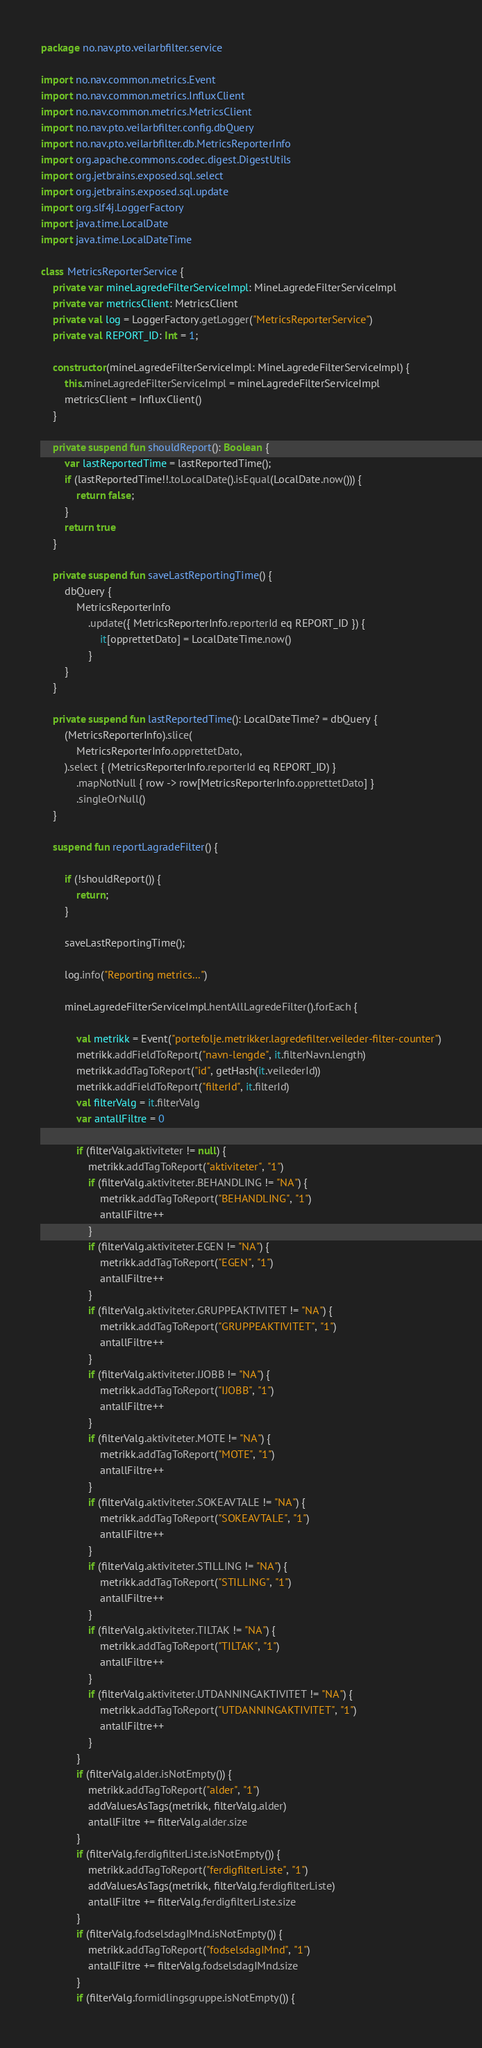Convert code to text. <code><loc_0><loc_0><loc_500><loc_500><_Kotlin_>package no.nav.pto.veilarbfilter.service

import no.nav.common.metrics.Event
import no.nav.common.metrics.InfluxClient
import no.nav.common.metrics.MetricsClient
import no.nav.pto.veilarbfilter.config.dbQuery
import no.nav.pto.veilarbfilter.db.MetricsReporterInfo
import org.apache.commons.codec.digest.DigestUtils
import org.jetbrains.exposed.sql.select
import org.jetbrains.exposed.sql.update
import org.slf4j.LoggerFactory
import java.time.LocalDate
import java.time.LocalDateTime

class MetricsReporterService {
    private var mineLagredeFilterServiceImpl: MineLagredeFilterServiceImpl
    private var metricsClient: MetricsClient
    private val log = LoggerFactory.getLogger("MetricsReporterService")
    private val REPORT_ID: Int = 1;

    constructor(mineLagredeFilterServiceImpl: MineLagredeFilterServiceImpl) {
        this.mineLagredeFilterServiceImpl = mineLagredeFilterServiceImpl
        metricsClient = InfluxClient()
    }

    private suspend fun shouldReport(): Boolean {
        var lastReportedTime = lastReportedTime();
        if (lastReportedTime!!.toLocalDate().isEqual(LocalDate.now())) {
            return false;
        }
        return true
    }

    private suspend fun saveLastReportingTime() {
        dbQuery {
            MetricsReporterInfo
                .update({ MetricsReporterInfo.reporterId eq REPORT_ID }) {
                    it[opprettetDato] = LocalDateTime.now()
                }
        }
    }

    private suspend fun lastReportedTime(): LocalDateTime? = dbQuery {
        (MetricsReporterInfo).slice(
            MetricsReporterInfo.opprettetDato,
        ).select { (MetricsReporterInfo.reporterId eq REPORT_ID) }
            .mapNotNull { row -> row[MetricsReporterInfo.opprettetDato] }
            .singleOrNull()
    }

    suspend fun reportLagradeFilter() {

        if (!shouldReport()) {
            return;
        }

        saveLastReportingTime();

        log.info("Reporting metrics...")

        mineLagredeFilterServiceImpl.hentAllLagredeFilter().forEach {

            val metrikk = Event("portefolje.metrikker.lagredefilter.veileder-filter-counter")
            metrikk.addFieldToReport("navn-lengde", it.filterNavn.length)
            metrikk.addTagToReport("id", getHash(it.veilederId))
            metrikk.addFieldToReport("filterId", it.filterId)
            val filterValg = it.filterValg
            var antallFiltre = 0

            if (filterValg.aktiviteter != null) {
                metrikk.addTagToReport("aktiviteter", "1")
                if (filterValg.aktiviteter.BEHANDLING != "NA") {
                    metrikk.addTagToReport("BEHANDLING", "1")
                    antallFiltre++
                }
                if (filterValg.aktiviteter.EGEN != "NA") {
                    metrikk.addTagToReport("EGEN", "1")
                    antallFiltre++
                }
                if (filterValg.aktiviteter.GRUPPEAKTIVITET != "NA") {
                    metrikk.addTagToReport("GRUPPEAKTIVITET", "1")
                    antallFiltre++
                }
                if (filterValg.aktiviteter.IJOBB != "NA") {
                    metrikk.addTagToReport("IJOBB", "1")
                    antallFiltre++
                }
                if (filterValg.aktiviteter.MOTE != "NA") {
                    metrikk.addTagToReport("MOTE", "1")
                    antallFiltre++
                }
                if (filterValg.aktiviteter.SOKEAVTALE != "NA") {
                    metrikk.addTagToReport("SOKEAVTALE", "1")
                    antallFiltre++
                }
                if (filterValg.aktiviteter.STILLING != "NA") {
                    metrikk.addTagToReport("STILLING", "1")
                    antallFiltre++
                }
                if (filterValg.aktiviteter.TILTAK != "NA") {
                    metrikk.addTagToReport("TILTAK", "1")
                    antallFiltre++
                }
                if (filterValg.aktiviteter.UTDANNINGAKTIVITET != "NA") {
                    metrikk.addTagToReport("UTDANNINGAKTIVITET", "1")
                    antallFiltre++
                }
            }
            if (filterValg.alder.isNotEmpty()) {
                metrikk.addTagToReport("alder", "1")
                addValuesAsTags(metrikk, filterValg.alder)
                antallFiltre += filterValg.alder.size
            }
            if (filterValg.ferdigfilterListe.isNotEmpty()) {
                metrikk.addTagToReport("ferdigfilterListe", "1")
                addValuesAsTags(metrikk, filterValg.ferdigfilterListe)
                antallFiltre += filterValg.ferdigfilterListe.size
            }
            if (filterValg.fodselsdagIMnd.isNotEmpty()) {
                metrikk.addTagToReport("fodselsdagIMnd", "1")
                antallFiltre += filterValg.fodselsdagIMnd.size
            }
            if (filterValg.formidlingsgruppe.isNotEmpty()) {</code> 